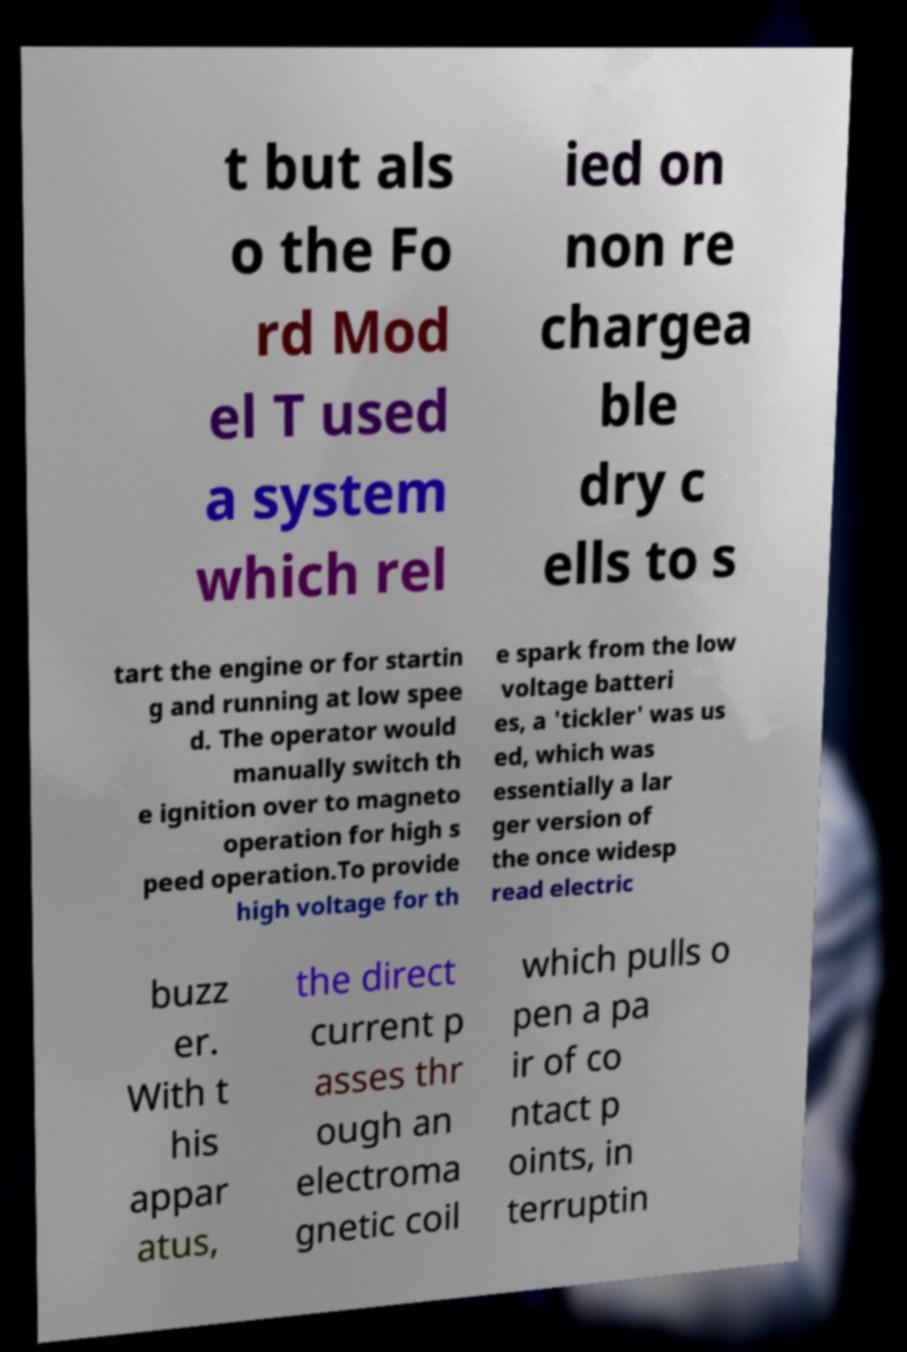Can you read and provide the text displayed in the image?This photo seems to have some interesting text. Can you extract and type it out for me? t but als o the Fo rd Mod el T used a system which rel ied on non re chargea ble dry c ells to s tart the engine or for startin g and running at low spee d. The operator would manually switch th e ignition over to magneto operation for high s peed operation.To provide high voltage for th e spark from the low voltage batteri es, a 'tickler' was us ed, which was essentially a lar ger version of the once widesp read electric buzz er. With t his appar atus, the direct current p asses thr ough an electroma gnetic coil which pulls o pen a pa ir of co ntact p oints, in terruptin 